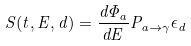Convert formula to latex. <formula><loc_0><loc_0><loc_500><loc_500>S ( t , E , d ) = \frac { d \Phi _ { a } } { d E } P _ { a \rightarrow \gamma } \epsilon _ { d }</formula> 